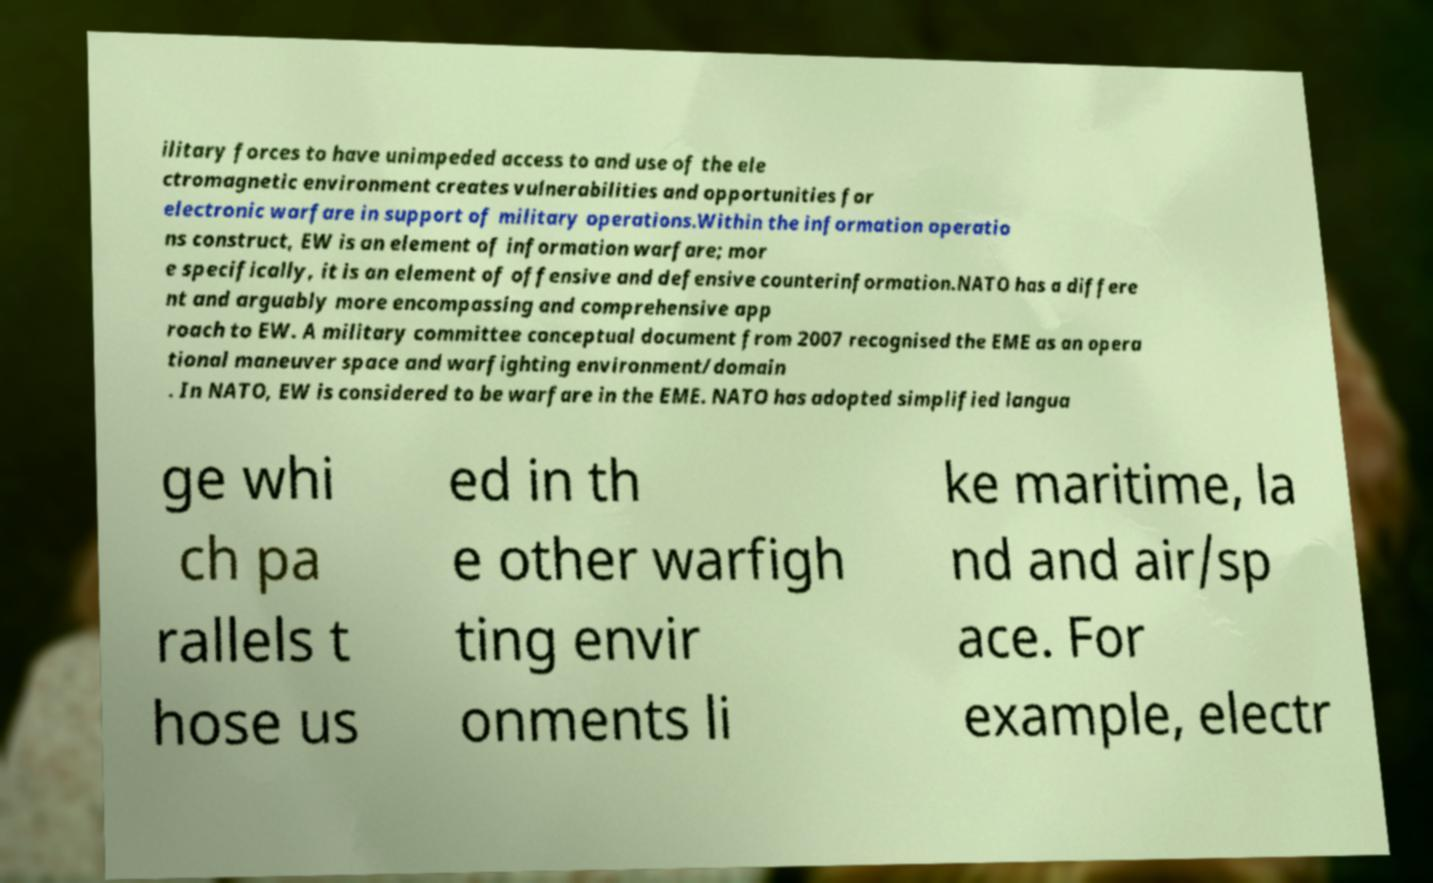Can you read and provide the text displayed in the image?This photo seems to have some interesting text. Can you extract and type it out for me? ilitary forces to have unimpeded access to and use of the ele ctromagnetic environment creates vulnerabilities and opportunities for electronic warfare in support of military operations.Within the information operatio ns construct, EW is an element of information warfare; mor e specifically, it is an element of offensive and defensive counterinformation.NATO has a differe nt and arguably more encompassing and comprehensive app roach to EW. A military committee conceptual document from 2007 recognised the EME as an opera tional maneuver space and warfighting environment/domain . In NATO, EW is considered to be warfare in the EME. NATO has adopted simplified langua ge whi ch pa rallels t hose us ed in th e other warfigh ting envir onments li ke maritime, la nd and air/sp ace. For example, electr 